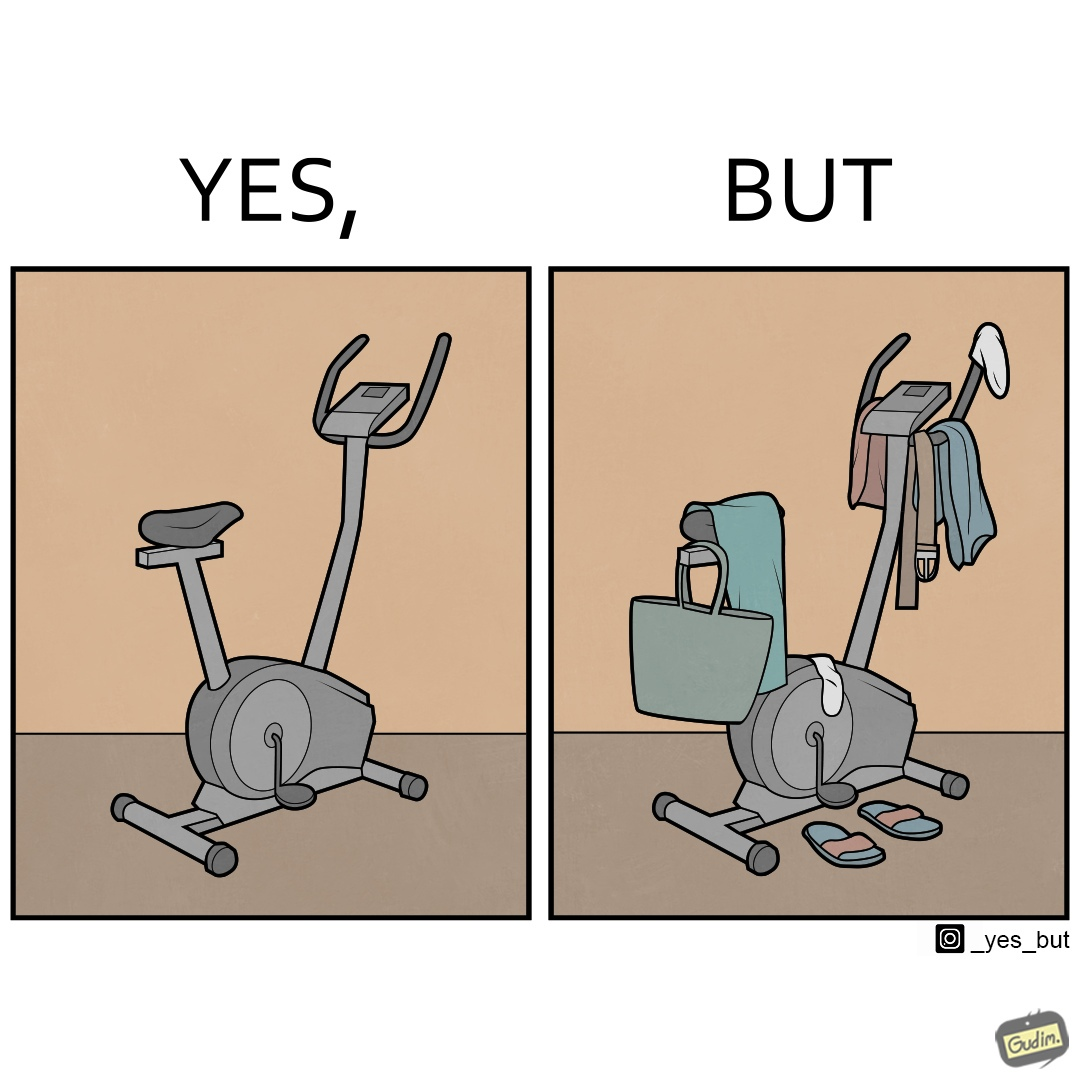Is there satirical content in this image? Yes, this image is satirical. 